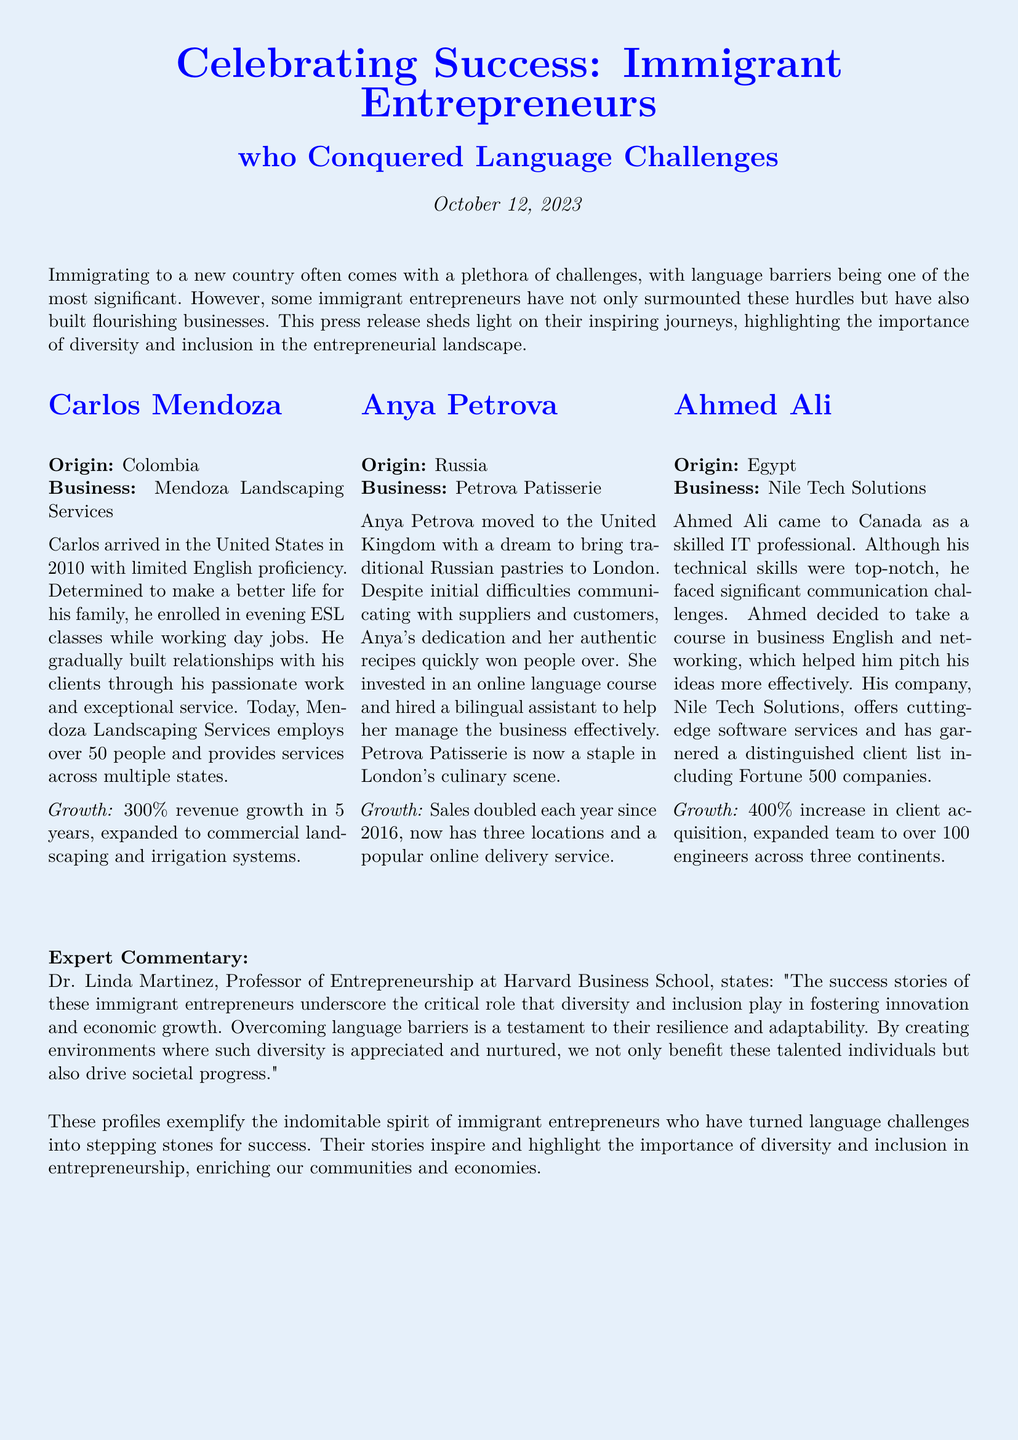what year did Carlos Mendoza arrive in the United States? The document states that Carlos Mendoza arrived in the United States in 2010.
Answer: 2010 how much revenue growth did Mendoza Landscaping Services achieve in 5 years? The document specifies that Mendoza Landscaping Services experienced a 300% revenue growth in 5 years.
Answer: 300% what is the name of Anya Petrova's business? The document mentions that Anya Petrova's business is called Petrova Patisserie.
Answer: Petrova Patisserie how many employees does Nile Tech Solutions have? The document states that Nile Tech Solutions expanded its team to over 100 engineers.
Answer: over 100 what common challenge did all three entrepreneurs face? The document indicates that all three entrepreneurs faced significant language barriers.
Answer: language barriers how many locations does Petrova Patisserie currently have? The document notes that Petrova Patisserie now has three locations.
Answer: three who is quoted in the expert commentary? The expert commentary features Dr. Linda Martinez.
Answer: Dr. Linda Martinez what is the industry of Ahmed Ali's business? The document states that Ahmed Ali's business, Nile Tech Solutions, operates in the software services industry.
Answer: software services why is diversity and inclusion highlighted in this press release? The document emphasizes that diversity and inclusion play a critical role in fostering innovation and economic growth.
Answer: innovation and economic growth 